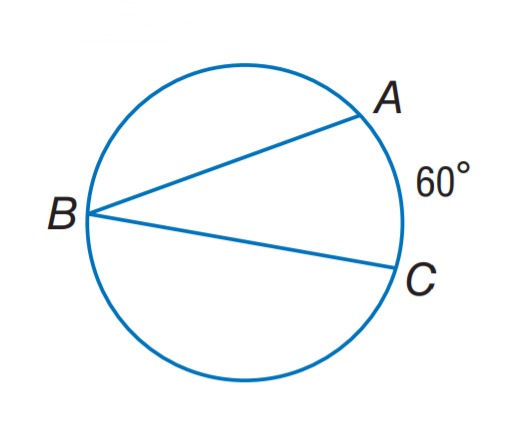Answer the mathemtical geometry problem and directly provide the correct option letter.
Question: Find m \angle B.
Choices: A: 20 B: 30 C: 60 D: 80 B 